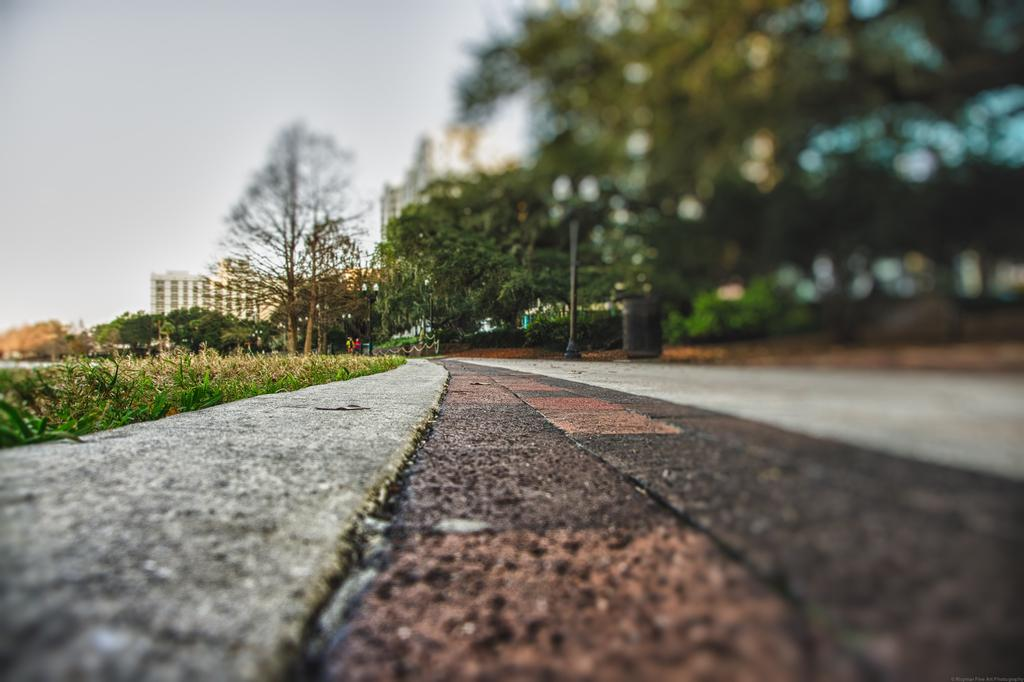What type of vegetation can be seen in the image? There is grass, plants, and trees in the image. Are there any man-made structures visible in the image? Yes, there are buildings in the image. What part of the natural environment is visible in the image? The sky is visible in the image. What type of bait is being used to catch fish in the image? There is no fishing or bait present in the image; it features grass, plants, trees, buildings, and the sky. 